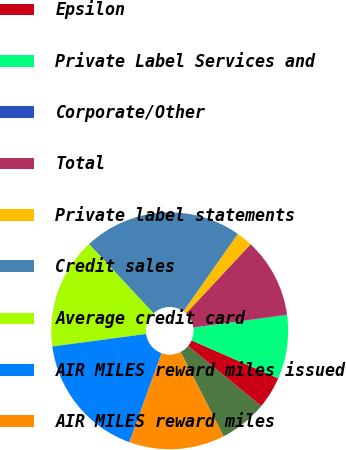<chart> <loc_0><loc_0><loc_500><loc_500><pie_chart><fcel>LoyaltyOne<fcel>Epsilon<fcel>Private Label Services and<fcel>Corporate/Other<fcel>Total<fcel>Private label statements<fcel>Credit sales<fcel>Average credit card<fcel>AIR MILES reward miles issued<fcel>AIR MILES reward miles<nl><fcel>6.54%<fcel>4.38%<fcel>8.7%<fcel>0.05%<fcel>10.87%<fcel>2.21%<fcel>21.68%<fcel>15.19%<fcel>17.36%<fcel>13.03%<nl></chart> 